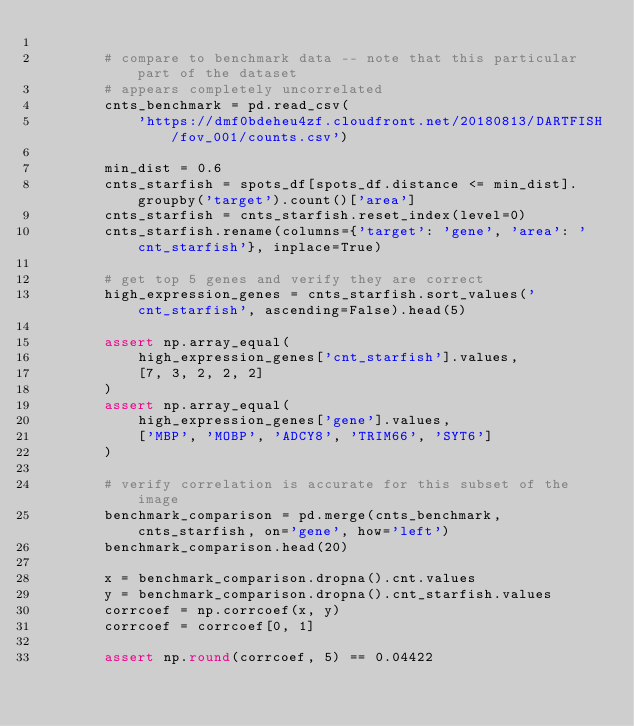Convert code to text. <code><loc_0><loc_0><loc_500><loc_500><_Python_>
        # compare to benchmark data -- note that this particular part of the dataset
        # appears completely uncorrelated
        cnts_benchmark = pd.read_csv(
            'https://dmf0bdeheu4zf.cloudfront.net/20180813/DARTFISH/fov_001/counts.csv')

        min_dist = 0.6
        cnts_starfish = spots_df[spots_df.distance <= min_dist].groupby('target').count()['area']
        cnts_starfish = cnts_starfish.reset_index(level=0)
        cnts_starfish.rename(columns={'target': 'gene', 'area': 'cnt_starfish'}, inplace=True)

        # get top 5 genes and verify they are correct
        high_expression_genes = cnts_starfish.sort_values('cnt_starfish', ascending=False).head(5)

        assert np.array_equal(
            high_expression_genes['cnt_starfish'].values,
            [7, 3, 2, 2, 2]
        )
        assert np.array_equal(
            high_expression_genes['gene'].values,
            ['MBP', 'MOBP', 'ADCY8', 'TRIM66', 'SYT6']
        )

        # verify correlation is accurate for this subset of the image
        benchmark_comparison = pd.merge(cnts_benchmark, cnts_starfish, on='gene', how='left')
        benchmark_comparison.head(20)

        x = benchmark_comparison.dropna().cnt.values
        y = benchmark_comparison.dropna().cnt_starfish.values
        corrcoef = np.corrcoef(x, y)
        corrcoef = corrcoef[0, 1]

        assert np.round(corrcoef, 5) == 0.04422
</code> 